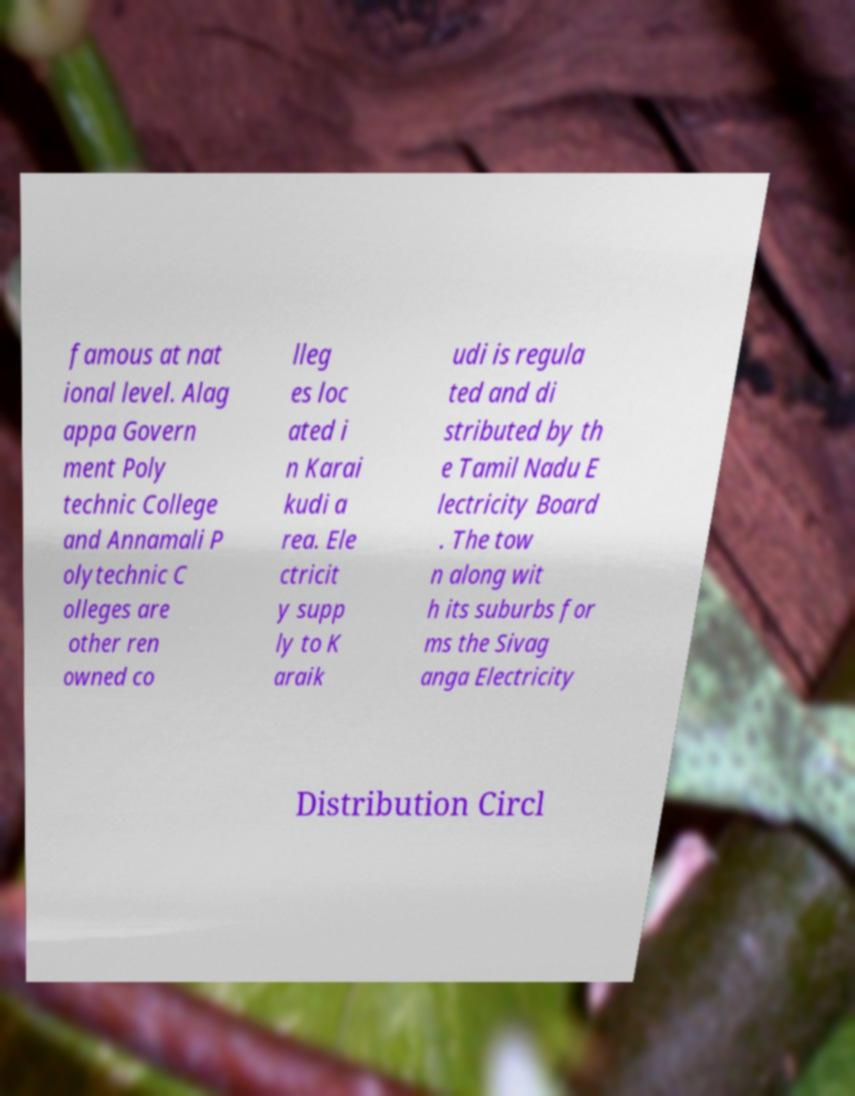For documentation purposes, I need the text within this image transcribed. Could you provide that? famous at nat ional level. Alag appa Govern ment Poly technic College and Annamali P olytechnic C olleges are other ren owned co lleg es loc ated i n Karai kudi a rea. Ele ctricit y supp ly to K araik udi is regula ted and di stributed by th e Tamil Nadu E lectricity Board . The tow n along wit h its suburbs for ms the Sivag anga Electricity Distribution Circl 